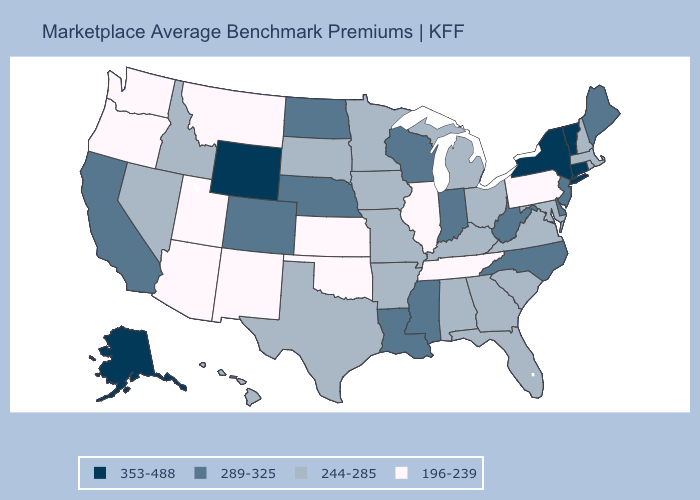Name the states that have a value in the range 353-488?
Keep it brief. Alaska, Connecticut, New York, Vermont, Wyoming. Which states have the highest value in the USA?
Concise answer only. Alaska, Connecticut, New York, Vermont, Wyoming. Name the states that have a value in the range 289-325?
Concise answer only. California, Colorado, Delaware, Indiana, Louisiana, Maine, Mississippi, Nebraska, New Jersey, North Carolina, North Dakota, West Virginia, Wisconsin. Among the states that border Georgia , which have the lowest value?
Keep it brief. Tennessee. How many symbols are there in the legend?
Short answer required. 4. What is the value of Maryland?
Give a very brief answer. 244-285. Among the states that border South Carolina , does North Carolina have the highest value?
Keep it brief. Yes. What is the value of Wyoming?
Concise answer only. 353-488. Does Indiana have the same value as Maine?
Answer briefly. Yes. Does West Virginia have the same value as Oregon?
Write a very short answer. No. Is the legend a continuous bar?
Give a very brief answer. No. Name the states that have a value in the range 289-325?
Short answer required. California, Colorado, Delaware, Indiana, Louisiana, Maine, Mississippi, Nebraska, New Jersey, North Carolina, North Dakota, West Virginia, Wisconsin. What is the value of Oregon?
Keep it brief. 196-239. Name the states that have a value in the range 244-285?
Keep it brief. Alabama, Arkansas, Florida, Georgia, Hawaii, Idaho, Iowa, Kentucky, Maryland, Massachusetts, Michigan, Minnesota, Missouri, Nevada, New Hampshire, Ohio, Rhode Island, South Carolina, South Dakota, Texas, Virginia. What is the value of Utah?
Answer briefly. 196-239. 